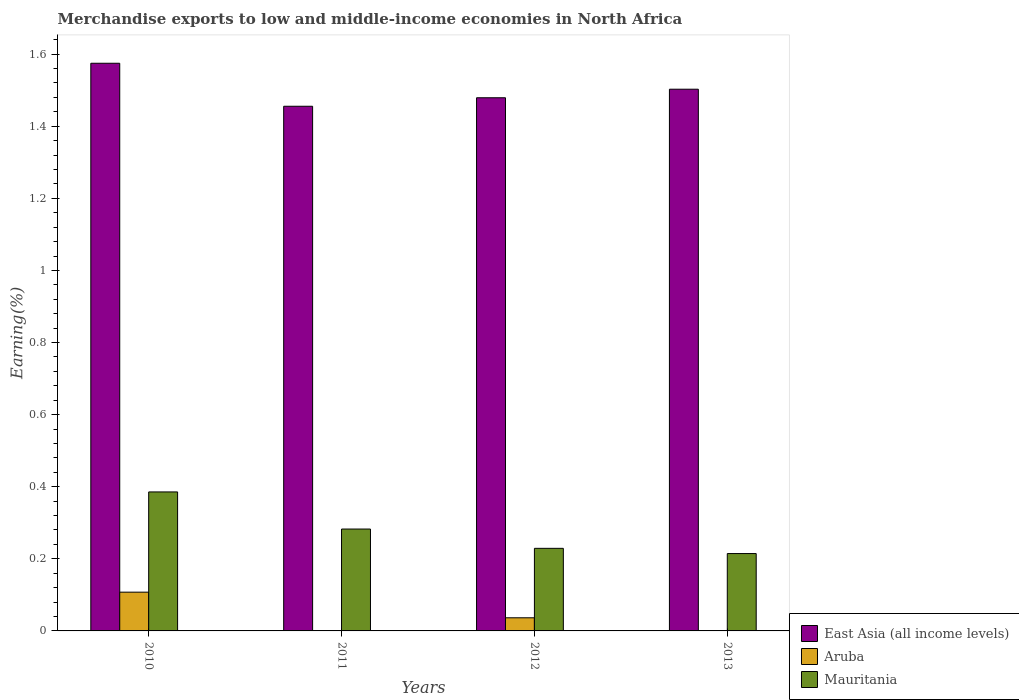Are the number of bars on each tick of the X-axis equal?
Your answer should be very brief. Yes. How many bars are there on the 4th tick from the left?
Make the answer very short. 3. How many bars are there on the 2nd tick from the right?
Your answer should be compact. 3. What is the percentage of amount earned from merchandise exports in Aruba in 2013?
Provide a short and direct response. 5.73259172769648e-5. Across all years, what is the maximum percentage of amount earned from merchandise exports in East Asia (all income levels)?
Offer a very short reply. 1.57. Across all years, what is the minimum percentage of amount earned from merchandise exports in East Asia (all income levels)?
Provide a succinct answer. 1.46. In which year was the percentage of amount earned from merchandise exports in Aruba minimum?
Ensure brevity in your answer.  2011. What is the total percentage of amount earned from merchandise exports in Aruba in the graph?
Give a very brief answer. 0.14. What is the difference between the percentage of amount earned from merchandise exports in Mauritania in 2010 and that in 2011?
Provide a short and direct response. 0.1. What is the difference between the percentage of amount earned from merchandise exports in East Asia (all income levels) in 2011 and the percentage of amount earned from merchandise exports in Mauritania in 2012?
Provide a short and direct response. 1.23. What is the average percentage of amount earned from merchandise exports in Mauritania per year?
Give a very brief answer. 0.28. In the year 2012, what is the difference between the percentage of amount earned from merchandise exports in Mauritania and percentage of amount earned from merchandise exports in East Asia (all income levels)?
Offer a terse response. -1.25. In how many years, is the percentage of amount earned from merchandise exports in Mauritania greater than 0.8400000000000001 %?
Make the answer very short. 0. What is the ratio of the percentage of amount earned from merchandise exports in Aruba in 2010 to that in 2012?
Offer a very short reply. 2.95. Is the difference between the percentage of amount earned from merchandise exports in Mauritania in 2011 and 2012 greater than the difference between the percentage of amount earned from merchandise exports in East Asia (all income levels) in 2011 and 2012?
Give a very brief answer. Yes. What is the difference between the highest and the second highest percentage of amount earned from merchandise exports in Mauritania?
Your answer should be very brief. 0.1. What is the difference between the highest and the lowest percentage of amount earned from merchandise exports in Aruba?
Your answer should be compact. 0.11. In how many years, is the percentage of amount earned from merchandise exports in Mauritania greater than the average percentage of amount earned from merchandise exports in Mauritania taken over all years?
Ensure brevity in your answer.  2. Is the sum of the percentage of amount earned from merchandise exports in Mauritania in 2011 and 2012 greater than the maximum percentage of amount earned from merchandise exports in Aruba across all years?
Provide a succinct answer. Yes. What does the 3rd bar from the left in 2010 represents?
Provide a succinct answer. Mauritania. What does the 3rd bar from the right in 2011 represents?
Provide a short and direct response. East Asia (all income levels). Is it the case that in every year, the sum of the percentage of amount earned from merchandise exports in Mauritania and percentage of amount earned from merchandise exports in Aruba is greater than the percentage of amount earned from merchandise exports in East Asia (all income levels)?
Your answer should be very brief. No. How many bars are there?
Keep it short and to the point. 12. Are all the bars in the graph horizontal?
Make the answer very short. No. What is the difference between two consecutive major ticks on the Y-axis?
Provide a short and direct response. 0.2. Does the graph contain any zero values?
Provide a succinct answer. No. Does the graph contain grids?
Make the answer very short. No. How many legend labels are there?
Ensure brevity in your answer.  3. How are the legend labels stacked?
Your answer should be very brief. Vertical. What is the title of the graph?
Provide a succinct answer. Merchandise exports to low and middle-income economies in North Africa. What is the label or title of the X-axis?
Your response must be concise. Years. What is the label or title of the Y-axis?
Your response must be concise. Earning(%). What is the Earning(%) in East Asia (all income levels) in 2010?
Offer a very short reply. 1.57. What is the Earning(%) of Aruba in 2010?
Keep it short and to the point. 0.11. What is the Earning(%) of Mauritania in 2010?
Give a very brief answer. 0.39. What is the Earning(%) of East Asia (all income levels) in 2011?
Your answer should be compact. 1.46. What is the Earning(%) in Aruba in 2011?
Give a very brief answer. 1.99365428786241e-5. What is the Earning(%) of Mauritania in 2011?
Your answer should be compact. 0.28. What is the Earning(%) of East Asia (all income levels) in 2012?
Keep it short and to the point. 1.48. What is the Earning(%) in Aruba in 2012?
Give a very brief answer. 0.04. What is the Earning(%) of Mauritania in 2012?
Offer a terse response. 0.23. What is the Earning(%) in East Asia (all income levels) in 2013?
Give a very brief answer. 1.5. What is the Earning(%) in Aruba in 2013?
Your answer should be compact. 5.73259172769648e-5. What is the Earning(%) in Mauritania in 2013?
Offer a terse response. 0.21. Across all years, what is the maximum Earning(%) in East Asia (all income levels)?
Your answer should be very brief. 1.57. Across all years, what is the maximum Earning(%) in Aruba?
Your answer should be very brief. 0.11. Across all years, what is the maximum Earning(%) in Mauritania?
Provide a succinct answer. 0.39. Across all years, what is the minimum Earning(%) in East Asia (all income levels)?
Offer a very short reply. 1.46. Across all years, what is the minimum Earning(%) of Aruba?
Offer a terse response. 1.99365428786241e-5. Across all years, what is the minimum Earning(%) of Mauritania?
Keep it short and to the point. 0.21. What is the total Earning(%) of East Asia (all income levels) in the graph?
Your answer should be compact. 6.01. What is the total Earning(%) of Aruba in the graph?
Provide a succinct answer. 0.14. What is the total Earning(%) in Mauritania in the graph?
Offer a terse response. 1.11. What is the difference between the Earning(%) of East Asia (all income levels) in 2010 and that in 2011?
Provide a succinct answer. 0.12. What is the difference between the Earning(%) in Aruba in 2010 and that in 2011?
Give a very brief answer. 0.11. What is the difference between the Earning(%) in Mauritania in 2010 and that in 2011?
Provide a succinct answer. 0.1. What is the difference between the Earning(%) in East Asia (all income levels) in 2010 and that in 2012?
Offer a terse response. 0.1. What is the difference between the Earning(%) of Aruba in 2010 and that in 2012?
Keep it short and to the point. 0.07. What is the difference between the Earning(%) in Mauritania in 2010 and that in 2012?
Offer a terse response. 0.16. What is the difference between the Earning(%) in East Asia (all income levels) in 2010 and that in 2013?
Keep it short and to the point. 0.07. What is the difference between the Earning(%) in Aruba in 2010 and that in 2013?
Your answer should be compact. 0.11. What is the difference between the Earning(%) of Mauritania in 2010 and that in 2013?
Offer a very short reply. 0.17. What is the difference between the Earning(%) in East Asia (all income levels) in 2011 and that in 2012?
Your response must be concise. -0.02. What is the difference between the Earning(%) in Aruba in 2011 and that in 2012?
Provide a short and direct response. -0.04. What is the difference between the Earning(%) of Mauritania in 2011 and that in 2012?
Your answer should be very brief. 0.05. What is the difference between the Earning(%) in East Asia (all income levels) in 2011 and that in 2013?
Ensure brevity in your answer.  -0.05. What is the difference between the Earning(%) of Aruba in 2011 and that in 2013?
Give a very brief answer. -0. What is the difference between the Earning(%) in Mauritania in 2011 and that in 2013?
Your answer should be compact. 0.07. What is the difference between the Earning(%) of East Asia (all income levels) in 2012 and that in 2013?
Your answer should be very brief. -0.02. What is the difference between the Earning(%) of Aruba in 2012 and that in 2013?
Give a very brief answer. 0.04. What is the difference between the Earning(%) of Mauritania in 2012 and that in 2013?
Offer a very short reply. 0.01. What is the difference between the Earning(%) of East Asia (all income levels) in 2010 and the Earning(%) of Aruba in 2011?
Provide a short and direct response. 1.57. What is the difference between the Earning(%) in East Asia (all income levels) in 2010 and the Earning(%) in Mauritania in 2011?
Your response must be concise. 1.29. What is the difference between the Earning(%) of Aruba in 2010 and the Earning(%) of Mauritania in 2011?
Your response must be concise. -0.18. What is the difference between the Earning(%) of East Asia (all income levels) in 2010 and the Earning(%) of Aruba in 2012?
Your response must be concise. 1.54. What is the difference between the Earning(%) in East Asia (all income levels) in 2010 and the Earning(%) in Mauritania in 2012?
Your answer should be compact. 1.35. What is the difference between the Earning(%) of Aruba in 2010 and the Earning(%) of Mauritania in 2012?
Offer a terse response. -0.12. What is the difference between the Earning(%) in East Asia (all income levels) in 2010 and the Earning(%) in Aruba in 2013?
Provide a short and direct response. 1.57. What is the difference between the Earning(%) in East Asia (all income levels) in 2010 and the Earning(%) in Mauritania in 2013?
Offer a terse response. 1.36. What is the difference between the Earning(%) in Aruba in 2010 and the Earning(%) in Mauritania in 2013?
Give a very brief answer. -0.11. What is the difference between the Earning(%) of East Asia (all income levels) in 2011 and the Earning(%) of Aruba in 2012?
Make the answer very short. 1.42. What is the difference between the Earning(%) in East Asia (all income levels) in 2011 and the Earning(%) in Mauritania in 2012?
Provide a short and direct response. 1.23. What is the difference between the Earning(%) of Aruba in 2011 and the Earning(%) of Mauritania in 2012?
Give a very brief answer. -0.23. What is the difference between the Earning(%) in East Asia (all income levels) in 2011 and the Earning(%) in Aruba in 2013?
Provide a short and direct response. 1.46. What is the difference between the Earning(%) of East Asia (all income levels) in 2011 and the Earning(%) of Mauritania in 2013?
Make the answer very short. 1.24. What is the difference between the Earning(%) in Aruba in 2011 and the Earning(%) in Mauritania in 2013?
Your answer should be compact. -0.21. What is the difference between the Earning(%) of East Asia (all income levels) in 2012 and the Earning(%) of Aruba in 2013?
Ensure brevity in your answer.  1.48. What is the difference between the Earning(%) of East Asia (all income levels) in 2012 and the Earning(%) of Mauritania in 2013?
Provide a succinct answer. 1.26. What is the difference between the Earning(%) of Aruba in 2012 and the Earning(%) of Mauritania in 2013?
Give a very brief answer. -0.18. What is the average Earning(%) in East Asia (all income levels) per year?
Give a very brief answer. 1.5. What is the average Earning(%) in Aruba per year?
Keep it short and to the point. 0.04. What is the average Earning(%) in Mauritania per year?
Offer a terse response. 0.28. In the year 2010, what is the difference between the Earning(%) in East Asia (all income levels) and Earning(%) in Aruba?
Ensure brevity in your answer.  1.47. In the year 2010, what is the difference between the Earning(%) of East Asia (all income levels) and Earning(%) of Mauritania?
Your answer should be compact. 1.19. In the year 2010, what is the difference between the Earning(%) of Aruba and Earning(%) of Mauritania?
Provide a short and direct response. -0.28. In the year 2011, what is the difference between the Earning(%) of East Asia (all income levels) and Earning(%) of Aruba?
Offer a very short reply. 1.46. In the year 2011, what is the difference between the Earning(%) of East Asia (all income levels) and Earning(%) of Mauritania?
Provide a succinct answer. 1.17. In the year 2011, what is the difference between the Earning(%) in Aruba and Earning(%) in Mauritania?
Give a very brief answer. -0.28. In the year 2012, what is the difference between the Earning(%) in East Asia (all income levels) and Earning(%) in Aruba?
Give a very brief answer. 1.44. In the year 2012, what is the difference between the Earning(%) in East Asia (all income levels) and Earning(%) in Mauritania?
Provide a succinct answer. 1.25. In the year 2012, what is the difference between the Earning(%) in Aruba and Earning(%) in Mauritania?
Your answer should be compact. -0.19. In the year 2013, what is the difference between the Earning(%) of East Asia (all income levels) and Earning(%) of Aruba?
Provide a succinct answer. 1.5. In the year 2013, what is the difference between the Earning(%) of East Asia (all income levels) and Earning(%) of Mauritania?
Offer a terse response. 1.29. In the year 2013, what is the difference between the Earning(%) in Aruba and Earning(%) in Mauritania?
Provide a succinct answer. -0.21. What is the ratio of the Earning(%) in East Asia (all income levels) in 2010 to that in 2011?
Provide a succinct answer. 1.08. What is the ratio of the Earning(%) in Aruba in 2010 to that in 2011?
Offer a terse response. 5391.54. What is the ratio of the Earning(%) in Mauritania in 2010 to that in 2011?
Provide a succinct answer. 1.36. What is the ratio of the Earning(%) of East Asia (all income levels) in 2010 to that in 2012?
Your response must be concise. 1.06. What is the ratio of the Earning(%) of Aruba in 2010 to that in 2012?
Offer a terse response. 2.95. What is the ratio of the Earning(%) in Mauritania in 2010 to that in 2012?
Your response must be concise. 1.68. What is the ratio of the Earning(%) in East Asia (all income levels) in 2010 to that in 2013?
Make the answer very short. 1.05. What is the ratio of the Earning(%) in Aruba in 2010 to that in 2013?
Provide a short and direct response. 1875.05. What is the ratio of the Earning(%) in Mauritania in 2010 to that in 2013?
Provide a short and direct response. 1.8. What is the ratio of the Earning(%) in East Asia (all income levels) in 2011 to that in 2012?
Give a very brief answer. 0.98. What is the ratio of the Earning(%) in Aruba in 2011 to that in 2012?
Make the answer very short. 0. What is the ratio of the Earning(%) of Mauritania in 2011 to that in 2012?
Your response must be concise. 1.23. What is the ratio of the Earning(%) in East Asia (all income levels) in 2011 to that in 2013?
Your answer should be compact. 0.97. What is the ratio of the Earning(%) in Aruba in 2011 to that in 2013?
Your answer should be very brief. 0.35. What is the ratio of the Earning(%) of Mauritania in 2011 to that in 2013?
Your answer should be compact. 1.32. What is the ratio of the Earning(%) in East Asia (all income levels) in 2012 to that in 2013?
Your answer should be compact. 0.98. What is the ratio of the Earning(%) in Aruba in 2012 to that in 2013?
Ensure brevity in your answer.  635.36. What is the ratio of the Earning(%) in Mauritania in 2012 to that in 2013?
Ensure brevity in your answer.  1.07. What is the difference between the highest and the second highest Earning(%) of East Asia (all income levels)?
Offer a very short reply. 0.07. What is the difference between the highest and the second highest Earning(%) of Aruba?
Offer a terse response. 0.07. What is the difference between the highest and the second highest Earning(%) in Mauritania?
Keep it short and to the point. 0.1. What is the difference between the highest and the lowest Earning(%) in East Asia (all income levels)?
Give a very brief answer. 0.12. What is the difference between the highest and the lowest Earning(%) of Aruba?
Make the answer very short. 0.11. What is the difference between the highest and the lowest Earning(%) in Mauritania?
Keep it short and to the point. 0.17. 